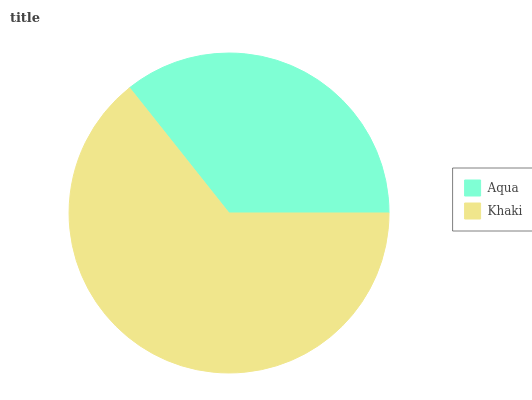Is Aqua the minimum?
Answer yes or no. Yes. Is Khaki the maximum?
Answer yes or no. Yes. Is Khaki the minimum?
Answer yes or no. No. Is Khaki greater than Aqua?
Answer yes or no. Yes. Is Aqua less than Khaki?
Answer yes or no. Yes. Is Aqua greater than Khaki?
Answer yes or no. No. Is Khaki less than Aqua?
Answer yes or no. No. Is Khaki the high median?
Answer yes or no. Yes. Is Aqua the low median?
Answer yes or no. Yes. Is Aqua the high median?
Answer yes or no. No. Is Khaki the low median?
Answer yes or no. No. 